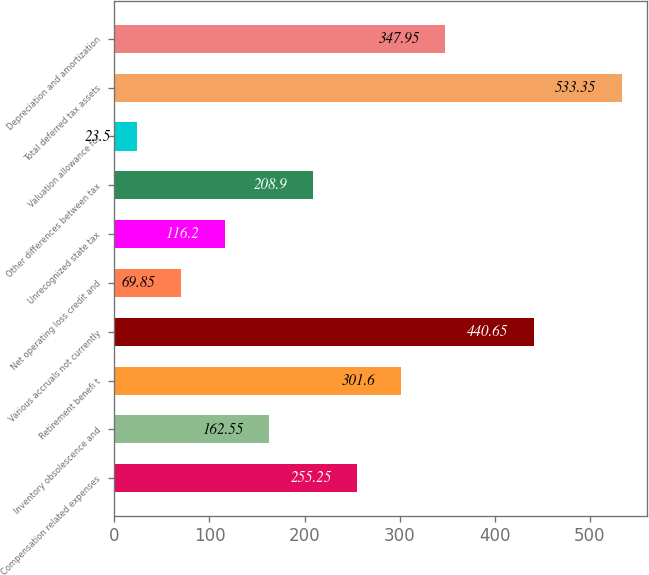<chart> <loc_0><loc_0><loc_500><loc_500><bar_chart><fcel>Compensation related expenses<fcel>Inventory obsolescence and<fcel>Retirement benefi t<fcel>Various accruals not currently<fcel>Net operating loss credit and<fcel>Unrecognized state tax<fcel>Other differences between tax<fcel>Valuation allowance for<fcel>Total deferred tax assets<fcel>Depreciation and amortization<nl><fcel>255.25<fcel>162.55<fcel>301.6<fcel>440.65<fcel>69.85<fcel>116.2<fcel>208.9<fcel>23.5<fcel>533.35<fcel>347.95<nl></chart> 